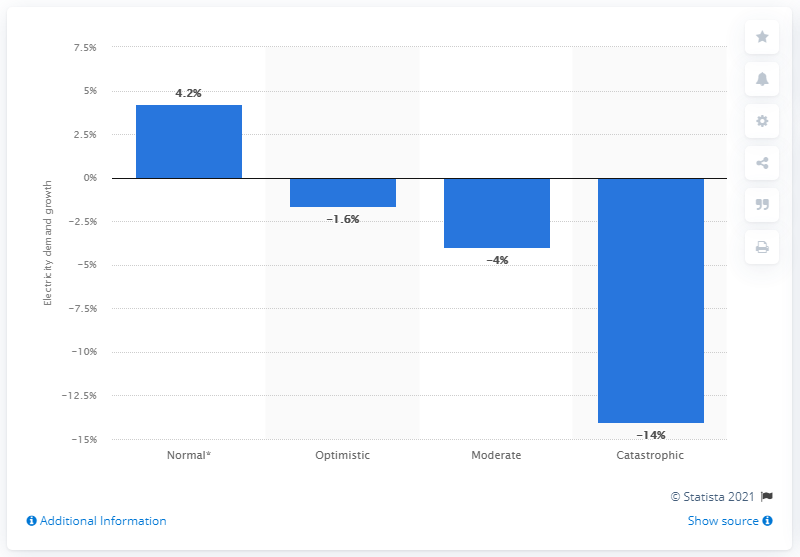List a handful of essential elements in this visual. Before the COVID-19 pandemic, Brazil's electricity demand was predicted to increase by 4.2% annually. 